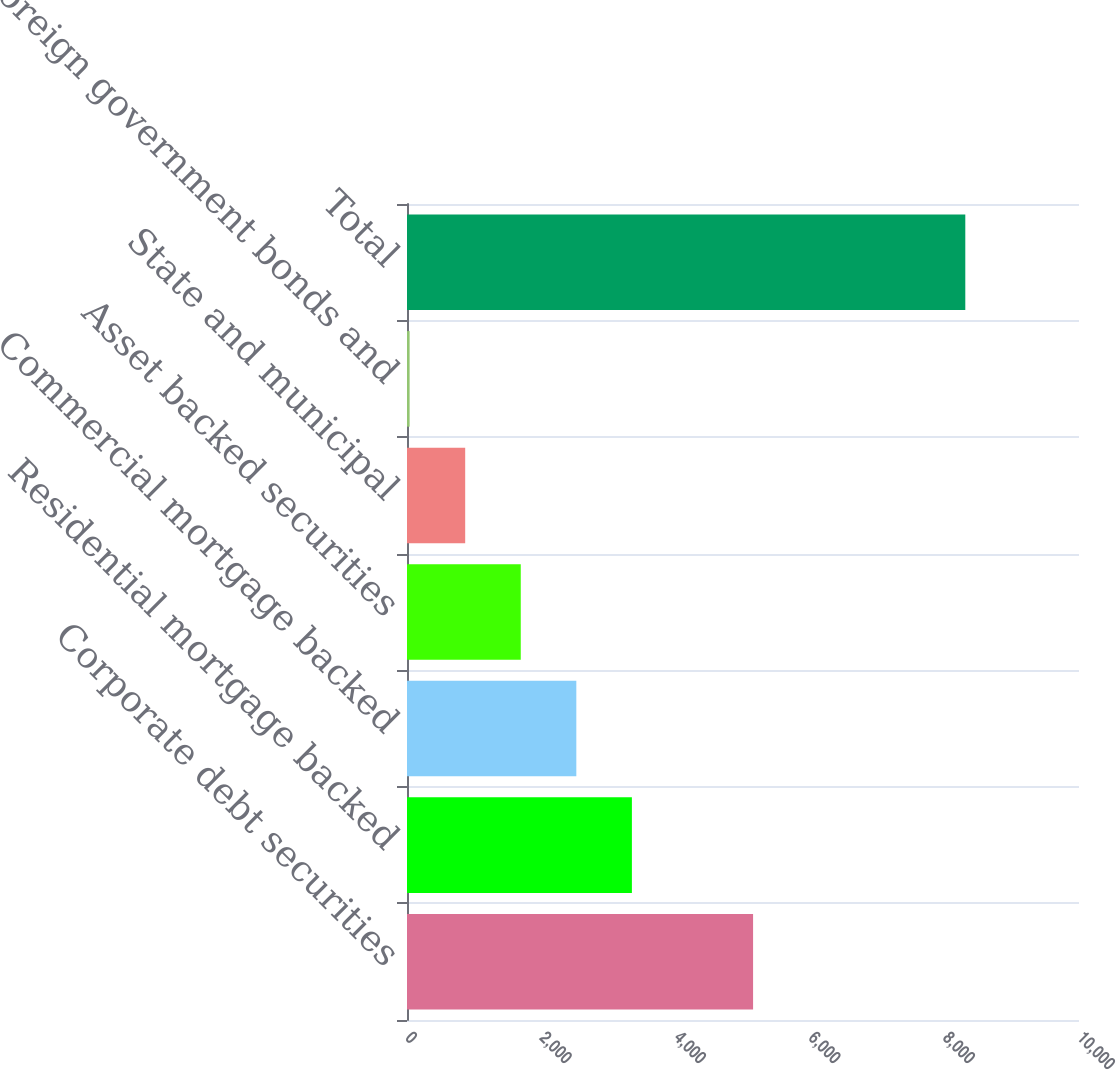Convert chart. <chart><loc_0><loc_0><loc_500><loc_500><bar_chart><fcel>Corporate debt securities<fcel>Residential mortgage backed<fcel>Commercial mortgage backed<fcel>Asset backed securities<fcel>State and municipal<fcel>Foreign government bonds and<fcel>Total<nl><fcel>5150<fcel>3346.6<fcel>2519.7<fcel>1692.8<fcel>865.9<fcel>39<fcel>8308<nl></chart> 